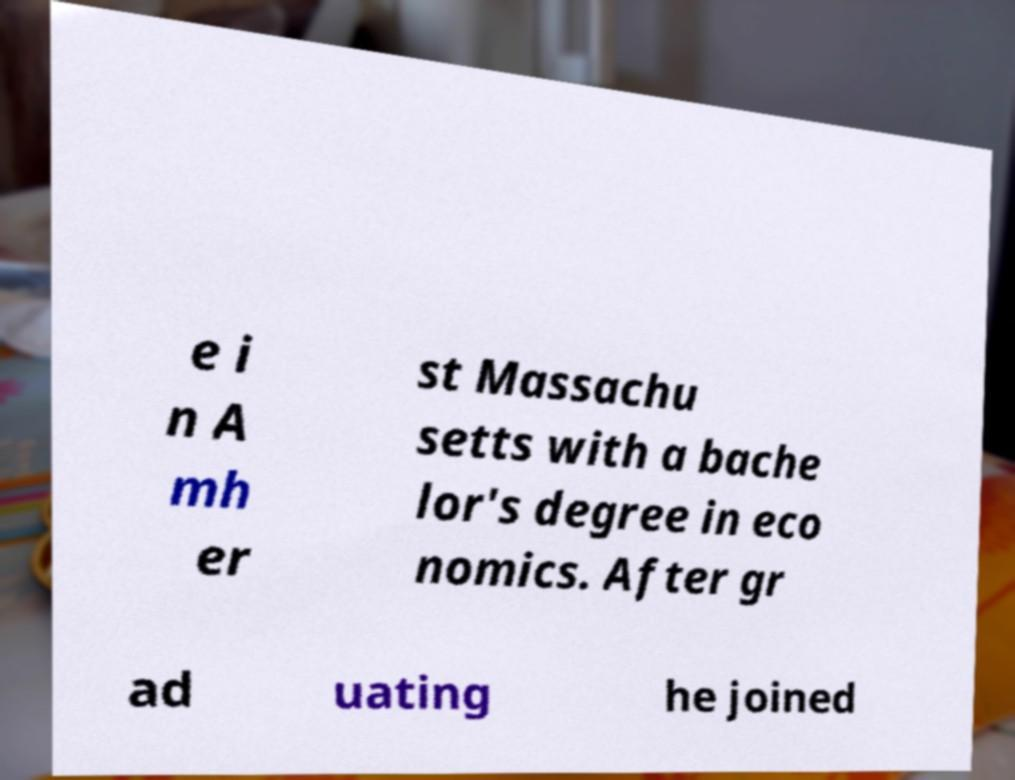Please identify and transcribe the text found in this image. e i n A mh er st Massachu setts with a bache lor's degree in eco nomics. After gr ad uating he joined 